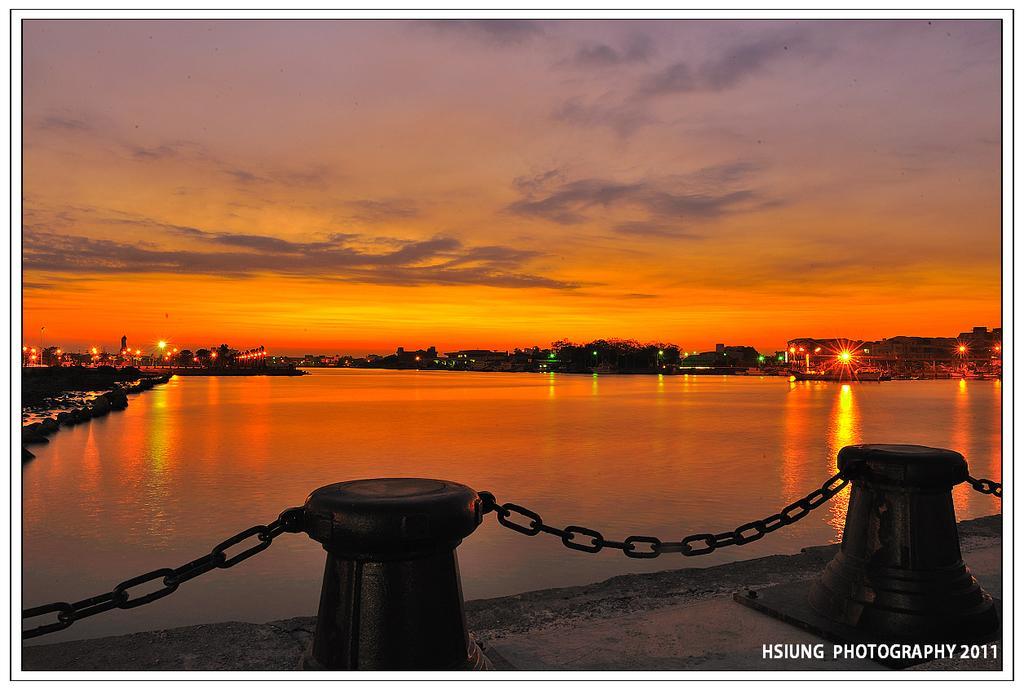Can you describe this image briefly? At the bottom of the image there are small poles with chains. Behind the wall there is water. In the background there are trees and lights. At the top of the image there is a sky with clouds. At the bottom right corner of the image there is a name. 